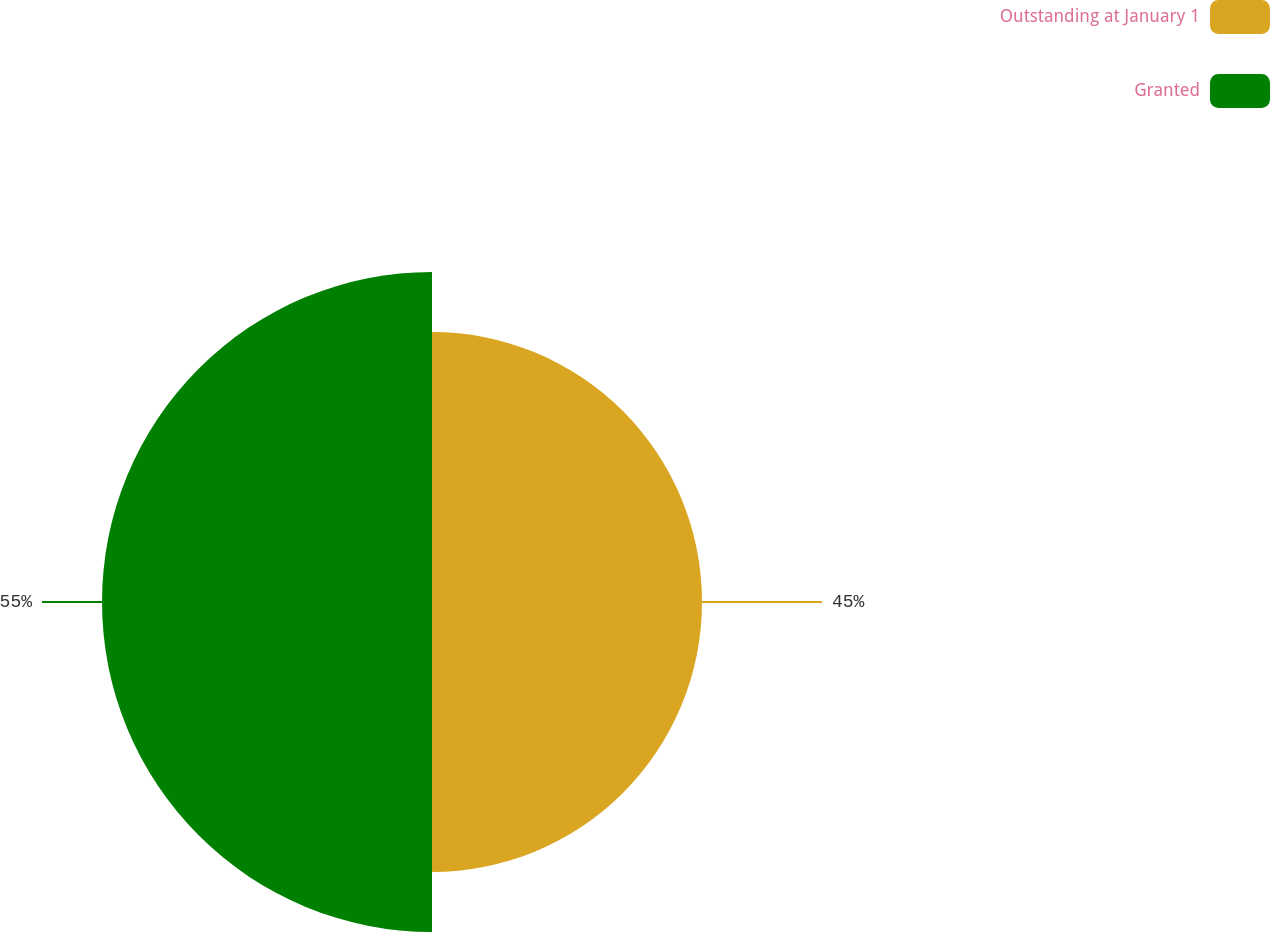<chart> <loc_0><loc_0><loc_500><loc_500><pie_chart><fcel>Outstanding at January 1<fcel>Granted<nl><fcel>45.0%<fcel>55.0%<nl></chart> 